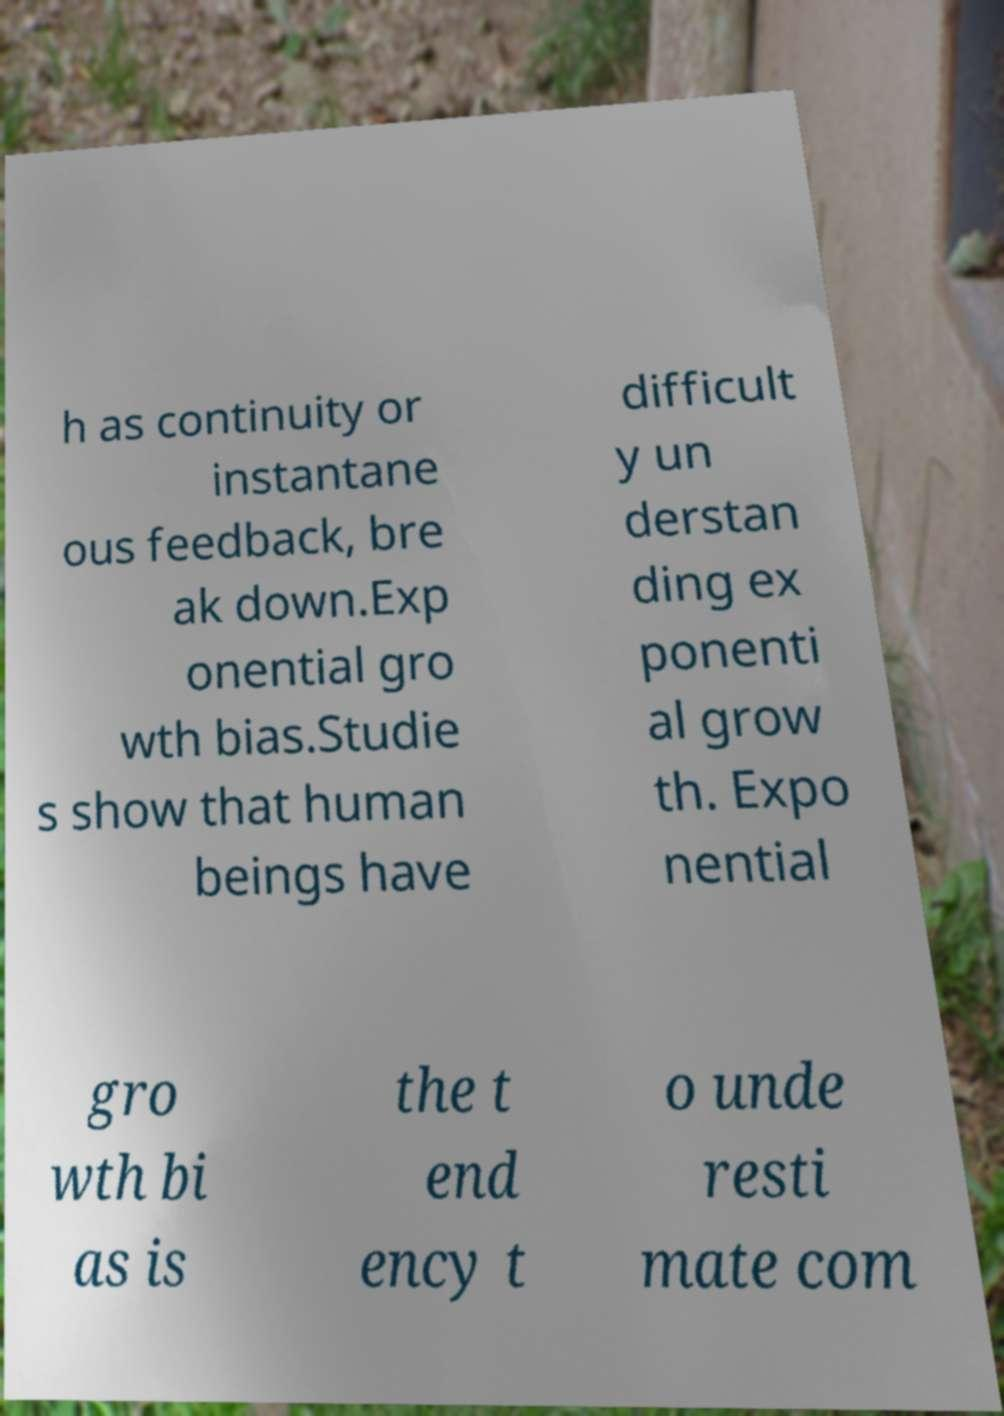Please identify and transcribe the text found in this image. h as continuity or instantane ous feedback, bre ak down.Exp onential gro wth bias.Studie s show that human beings have difficult y un derstan ding ex ponenti al grow th. Expo nential gro wth bi as is the t end ency t o unde resti mate com 